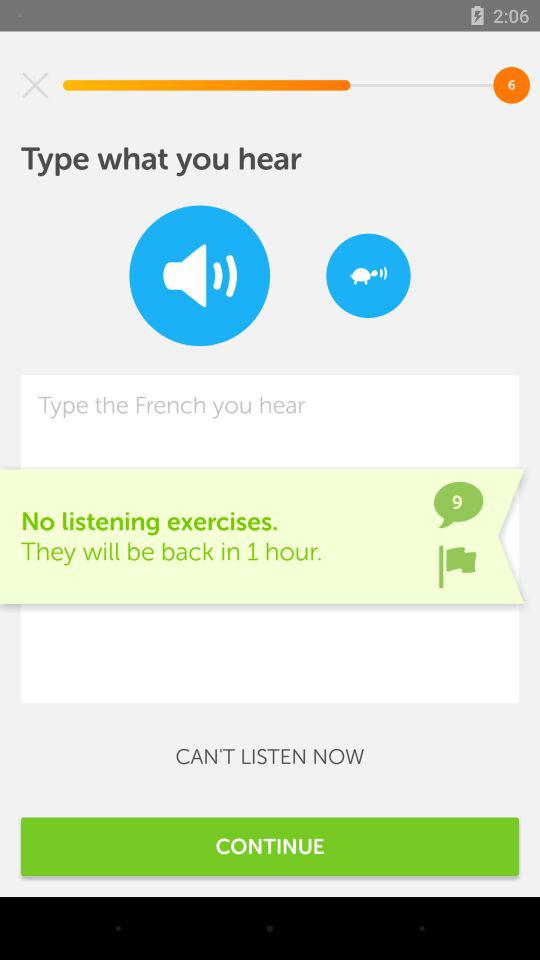What time will they return? They will return in 1 hour. 